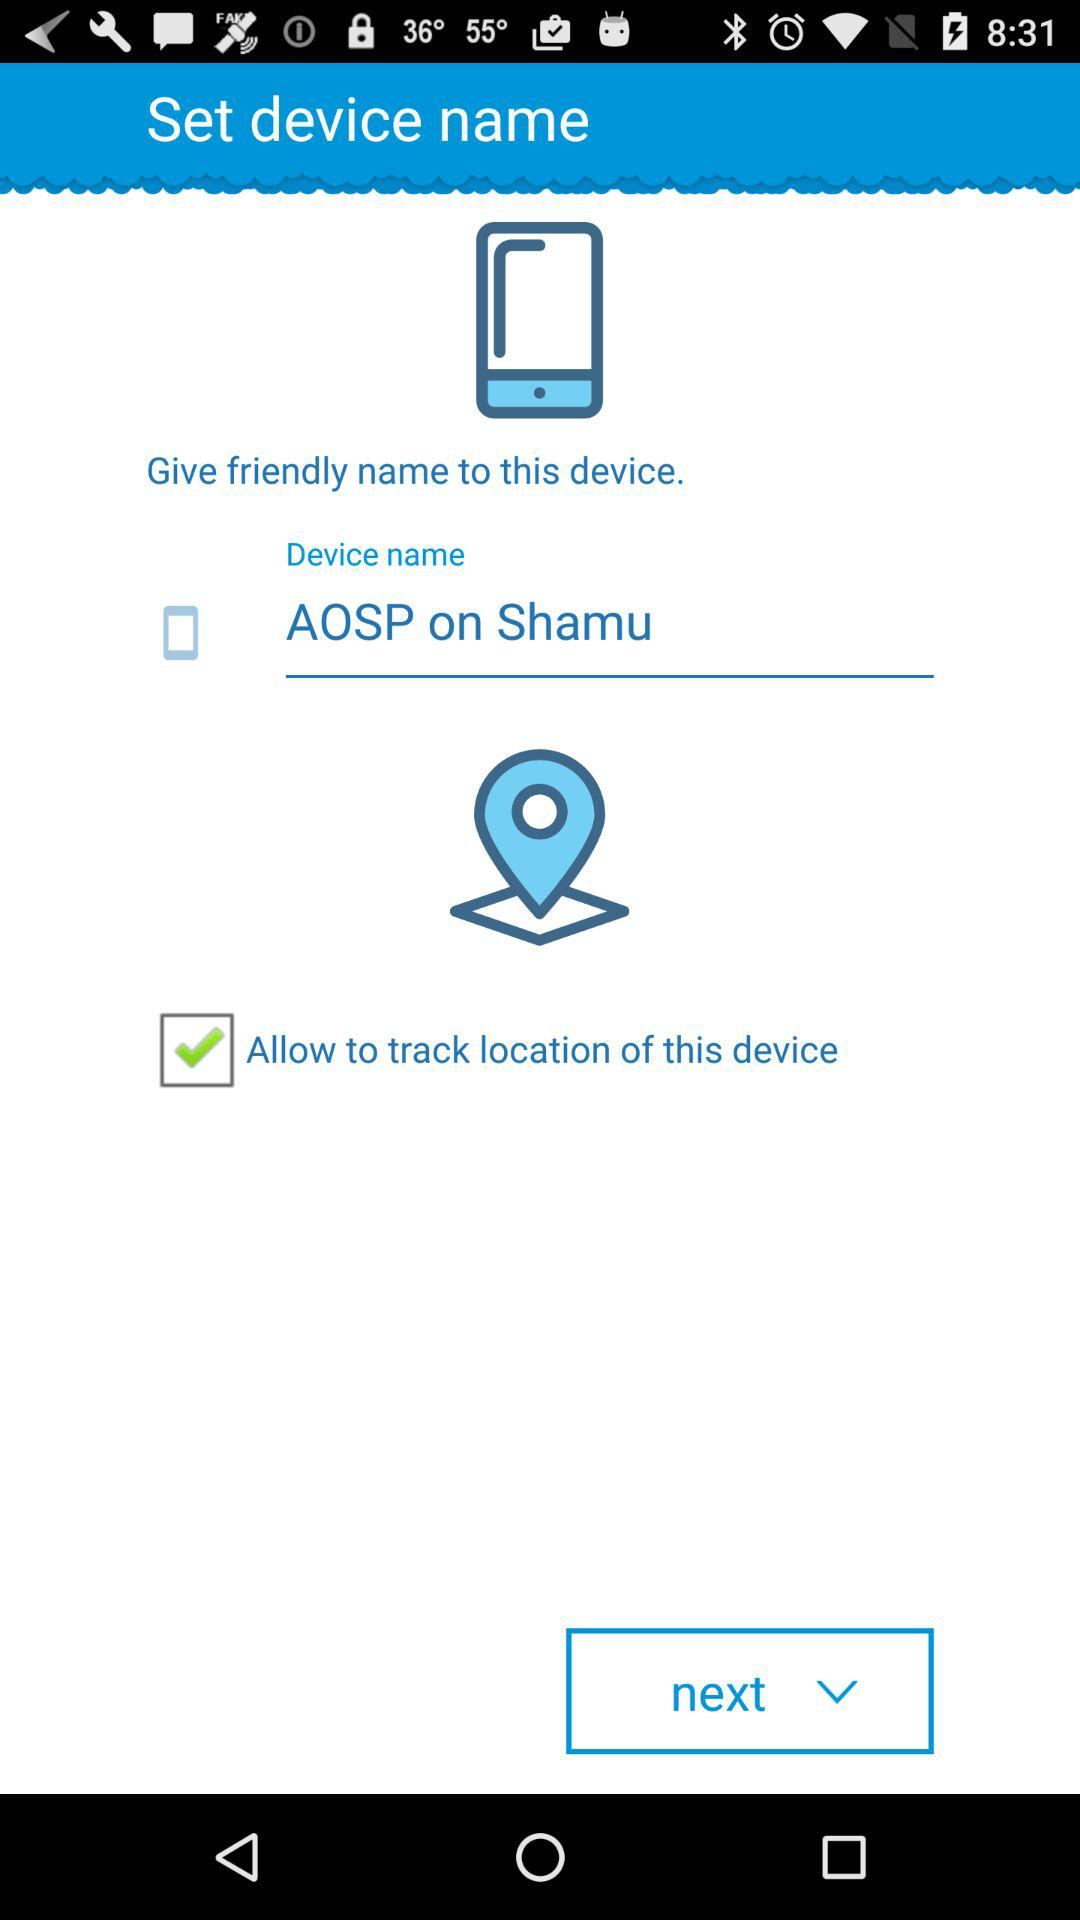What is the device name? The device name is "AOSP on Shamu". 